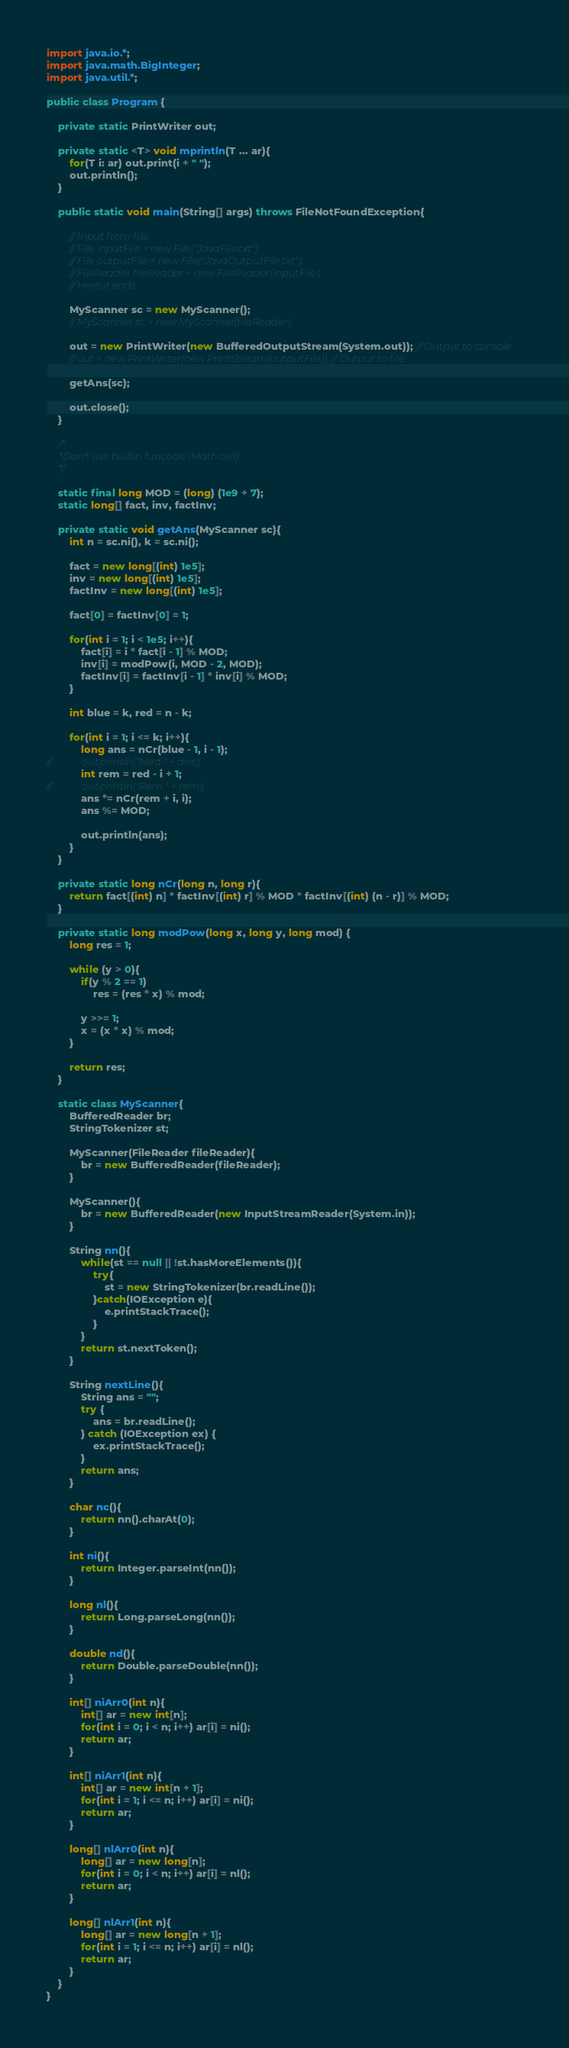Convert code to text. <code><loc_0><loc_0><loc_500><loc_500><_Java_>import java.io.*;
import java.math.BigInteger;
import java.util.*;

public class Program {

    private static PrintWriter out;

    private static <T> void mprintln(T ... ar){
        for(T i: ar) out.print(i + " ");
        out.println();
    }

    public static void main(String[] args) throws FileNotFoundException{

        // Input from file
        // File inputFile = new File("JavaFile.txt");
        // File outputFile = new File("JavaOutputFile.txt");
        // FileReader fileReader = new FileReader(inputFile);
        // Here it ends

        MyScanner sc = new MyScanner();
        // MyScanner sc = new MyScanner(fileReader);

        out = new PrintWriter(new BufferedOutputStream(System.out)); // Output to console
        // out = new PrintWriter(new PrintStream(outputFile)); // Output to file

        getAns(sc);

        out.close();
    }

    /*
     *Don't use builtin function (Math.ceil)
     */

    static final long MOD = (long) (1e9 + 7);
    static long[] fact, inv, factInv;

    private static void getAns(MyScanner sc){
        int n = sc.ni(), k = sc.ni();

        fact = new long[(int) 1e5];
        inv = new long[(int) 1e5];
        factInv = new long[(int) 1e5];

        fact[0] = factInv[0] = 1;

        for(int i = 1; i < 1e5; i++){
            fact[i] = i * fact[i - 1] % MOD;
            inv[i] = modPow(i, MOD - 2, MOD);
            factInv[i] = factInv[i - 1] * inv[i] % MOD;
        }

        int blue = k, red = n - k;

        for(int i = 1; i <= k; i++){
            long ans = nCr(blue - 1, i - 1);
//            out.println("Med " + ans);
            int rem = red - i + 1;
//            out.println("Rem " + rem);
            ans *= nCr(rem + i, i);
            ans %= MOD;

            out.println(ans);
        }
    }

    private static long nCr(long n, long r){
        return fact[(int) n] * factInv[(int) r] % MOD * factInv[(int) (n - r)] % MOD;
    }

    private static long modPow(long x, long y, long mod) {
        long res = 1;

        while (y > 0){
            if(y % 2 == 1)
                res = (res * x) % mod;

            y >>= 1;
            x = (x * x) % mod;
        }

        return res;
    }

    static class MyScanner{
        BufferedReader br;
        StringTokenizer st;

        MyScanner(FileReader fileReader){
            br = new BufferedReader(fileReader);
        }

        MyScanner(){
            br = new BufferedReader(new InputStreamReader(System.in));
        }

        String nn(){
            while(st == null || !st.hasMoreElements()){
                try{
                    st = new StringTokenizer(br.readLine());
                }catch(IOException e){
                    e.printStackTrace();
                }
            }
            return st.nextToken();
        }

        String nextLine(){
            String ans = "";
            try {
                ans = br.readLine();
            } catch (IOException ex) {
                ex.printStackTrace();
            }
            return ans;
        }

        char nc(){
            return nn().charAt(0);
        }

        int ni(){
            return Integer.parseInt(nn());
        }

        long nl(){
            return Long.parseLong(nn());
        }

        double nd(){
            return Double.parseDouble(nn());
        }

        int[] niArr0(int n){
            int[] ar = new int[n];
            for(int i = 0; i < n; i++) ar[i] = ni();
            return ar;
        }

        int[] niArr1(int n){
            int[] ar = new int[n + 1];
            for(int i = 1; i <= n; i++) ar[i] = ni();
            return ar;
        }

        long[] nlArr0(int n){
            long[] ar = new long[n];
            for(int i = 0; i < n; i++) ar[i] = nl();
            return ar;
        }

        long[] nlArr1(int n){
            long[] ar = new long[n + 1];
            for(int i = 1; i <= n; i++) ar[i] = nl();
            return ar;
        }
    }
}</code> 